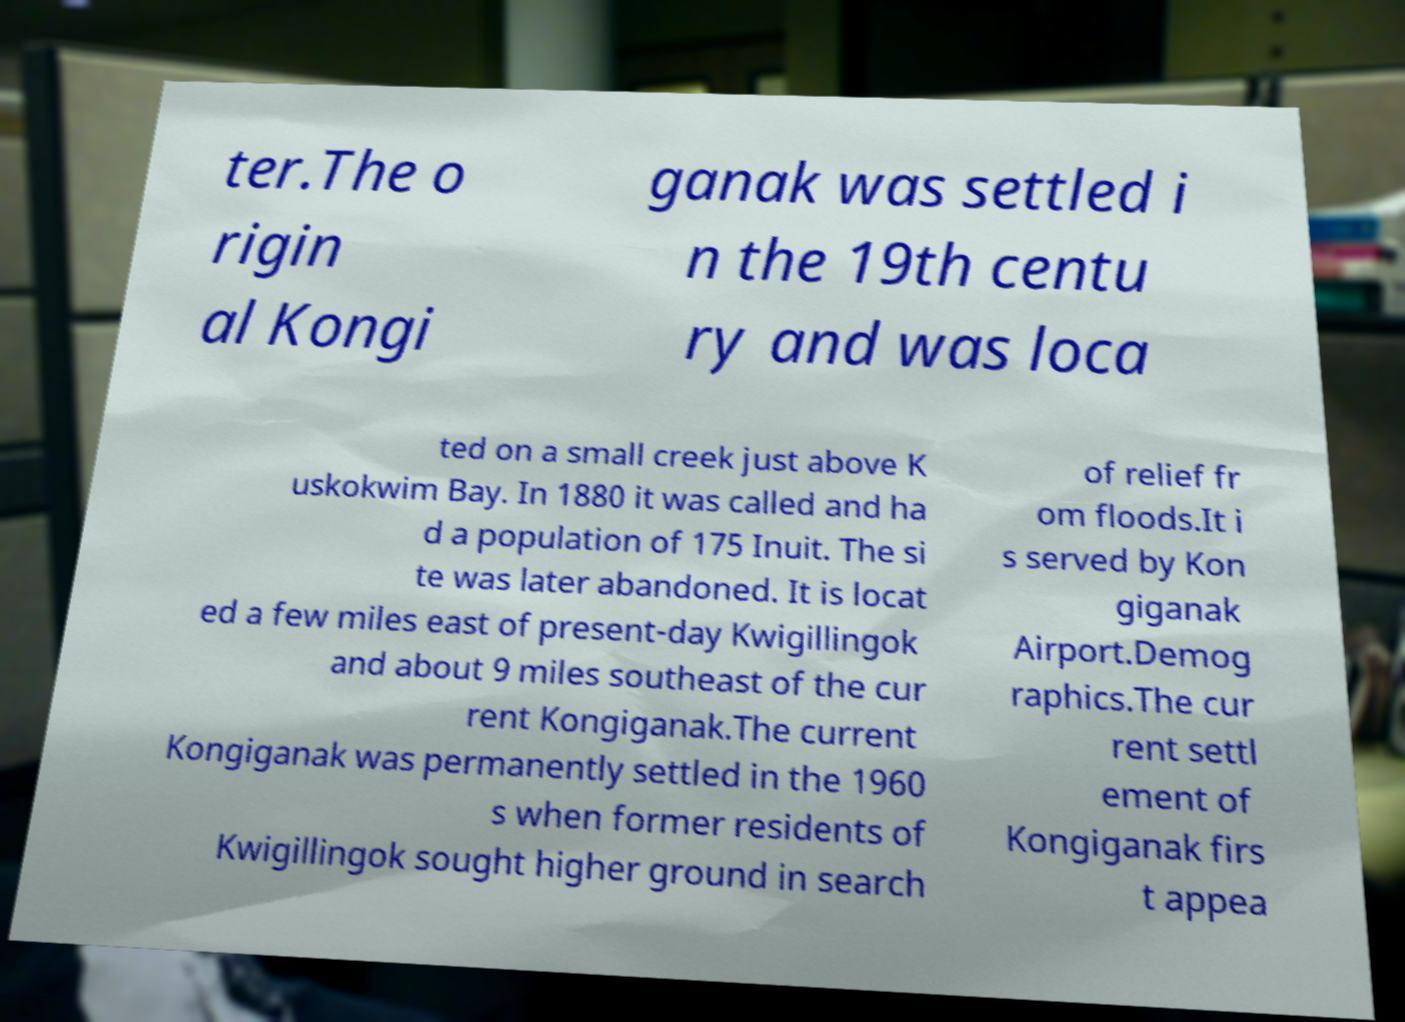Can you read and provide the text displayed in the image?This photo seems to have some interesting text. Can you extract and type it out for me? ter.The o rigin al Kongi ganak was settled i n the 19th centu ry and was loca ted on a small creek just above K uskokwim Bay. In 1880 it was called and ha d a population of 175 Inuit. The si te was later abandoned. It is locat ed a few miles east of present-day Kwigillingok and about 9 miles southeast of the cur rent Kongiganak.The current Kongiganak was permanently settled in the 1960 s when former residents of Kwigillingok sought higher ground in search of relief fr om floods.It i s served by Kon giganak Airport.Demog raphics.The cur rent settl ement of Kongiganak firs t appea 